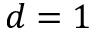Convert formula to latex. <formula><loc_0><loc_0><loc_500><loc_500>d = 1</formula> 